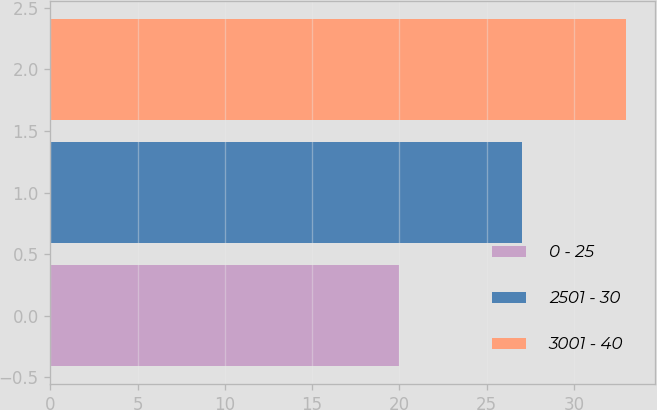Convert chart. <chart><loc_0><loc_0><loc_500><loc_500><bar_chart><fcel>0 - 25<fcel>2501 - 30<fcel>3001 - 40<nl><fcel>20<fcel>27<fcel>33<nl></chart> 